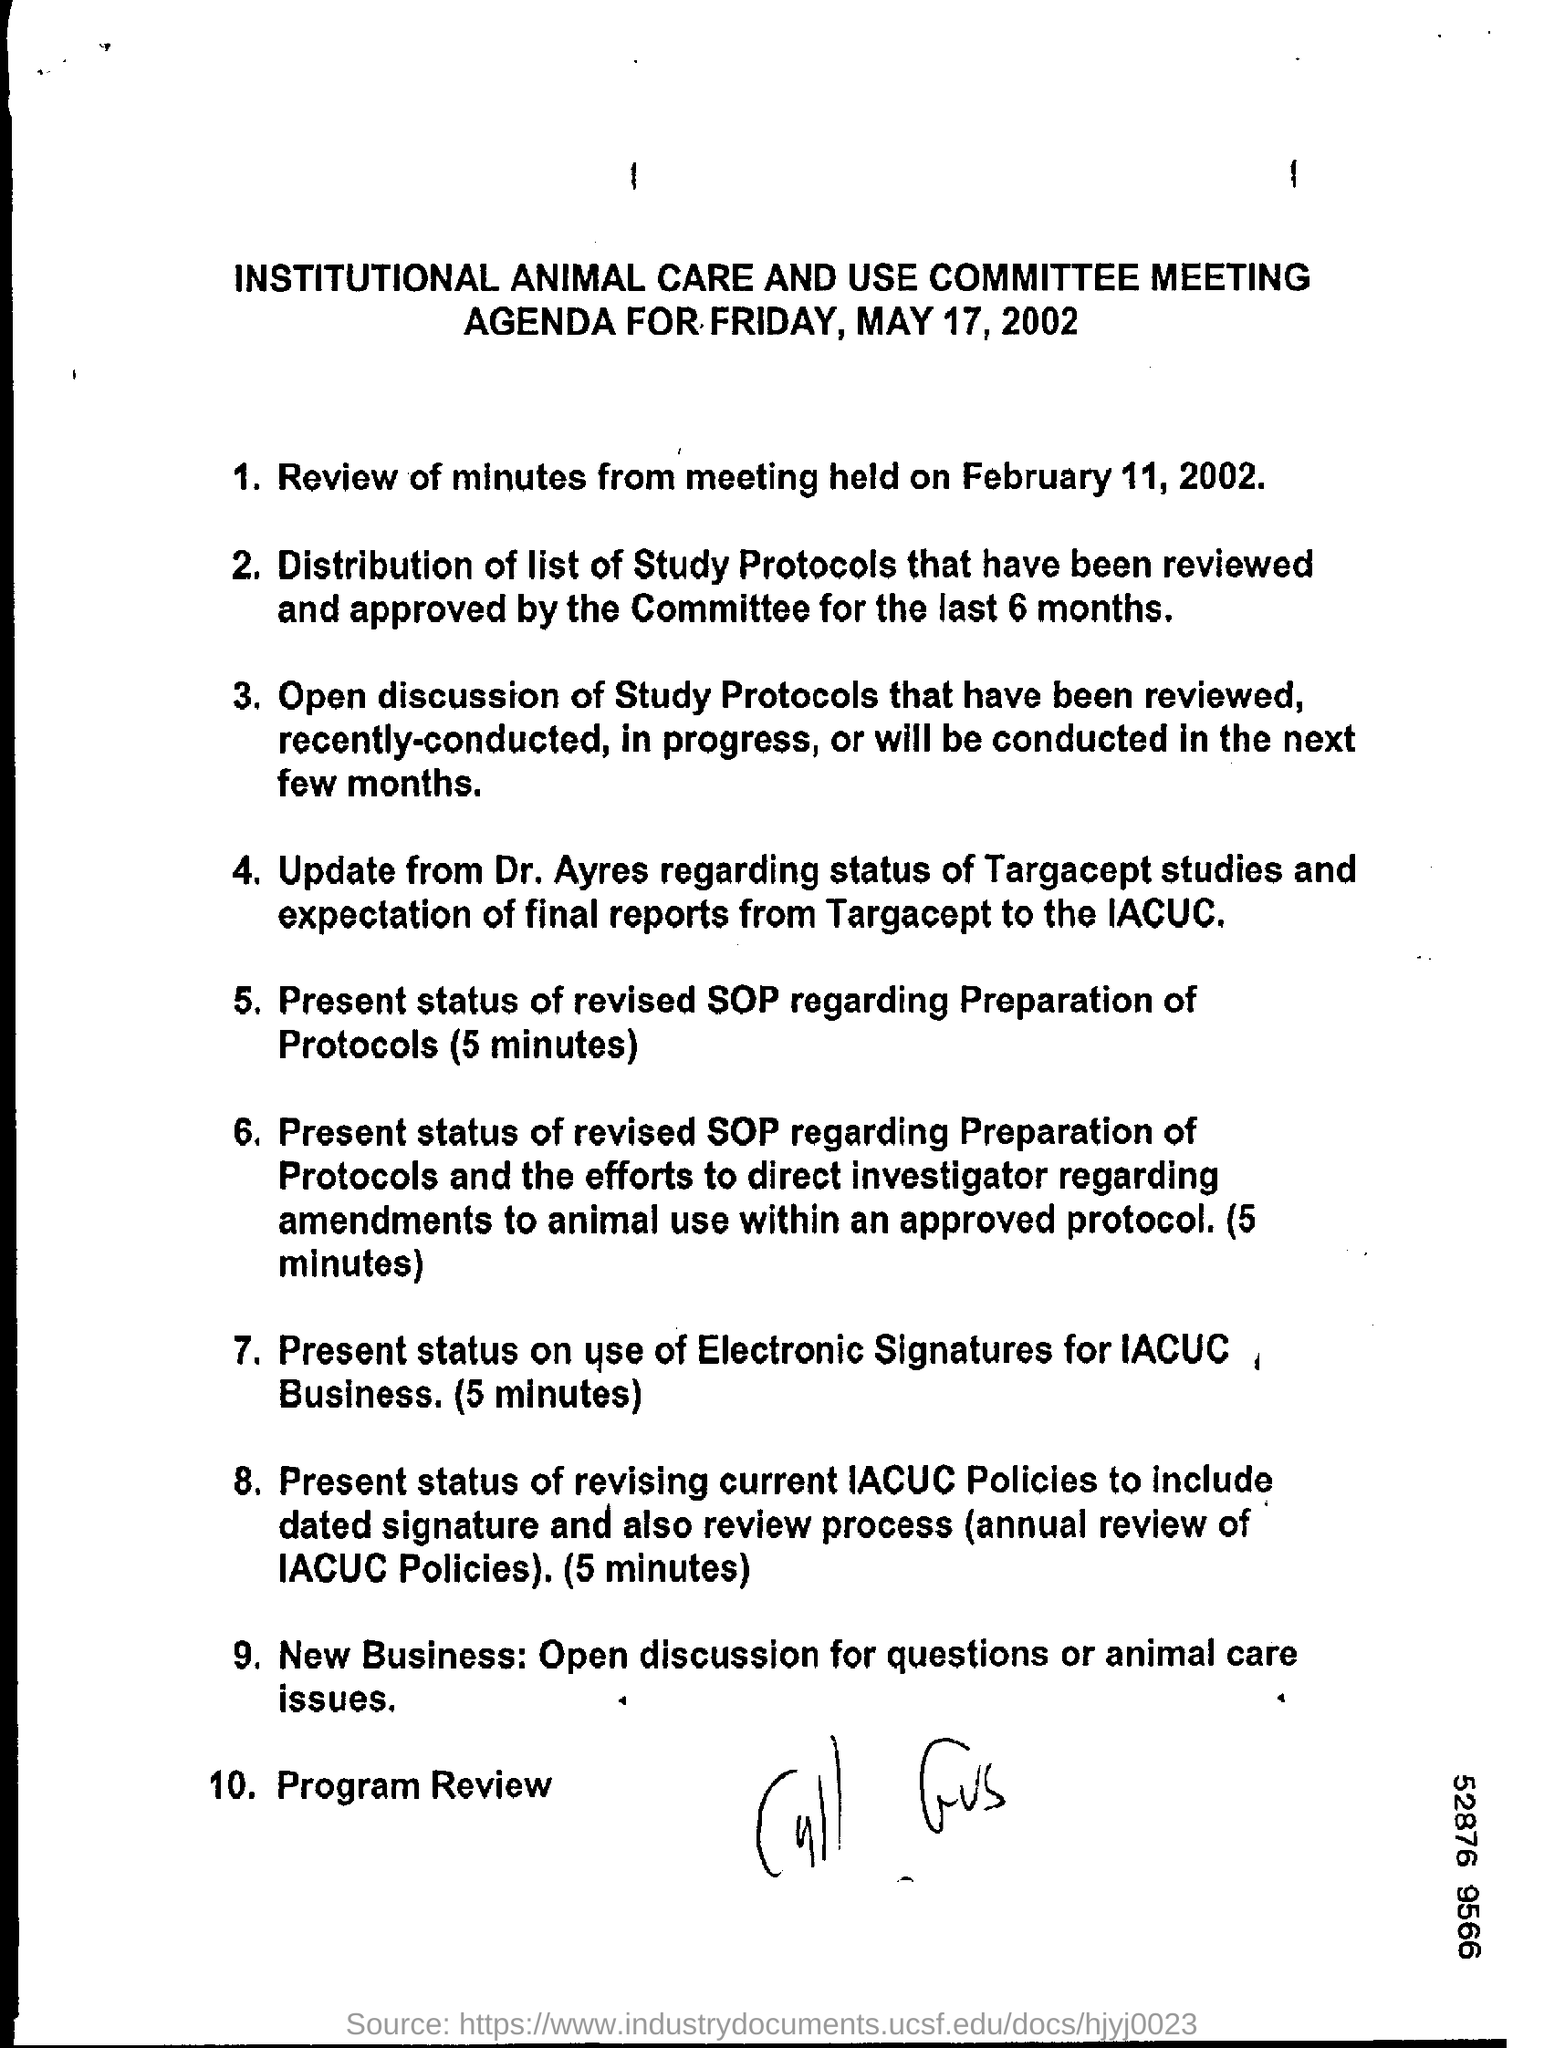Outline some significant characteristics in this image. The final point on the agenda is Program Review. The Institutional Animal Care and Use Committee Meeting is mentioned. It is Dr. Ayres' responsibility to update the status of Targacept studies. The agenda for Friday, May 17, 2002, will be announced. 